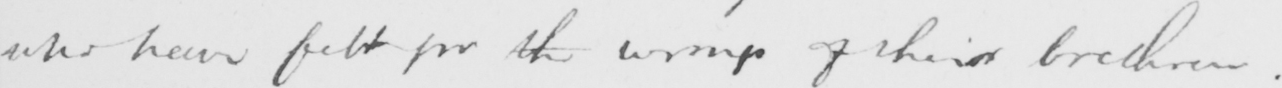Can you tell me what this handwritten text says? who have felt for the wrongs of their brethren . 